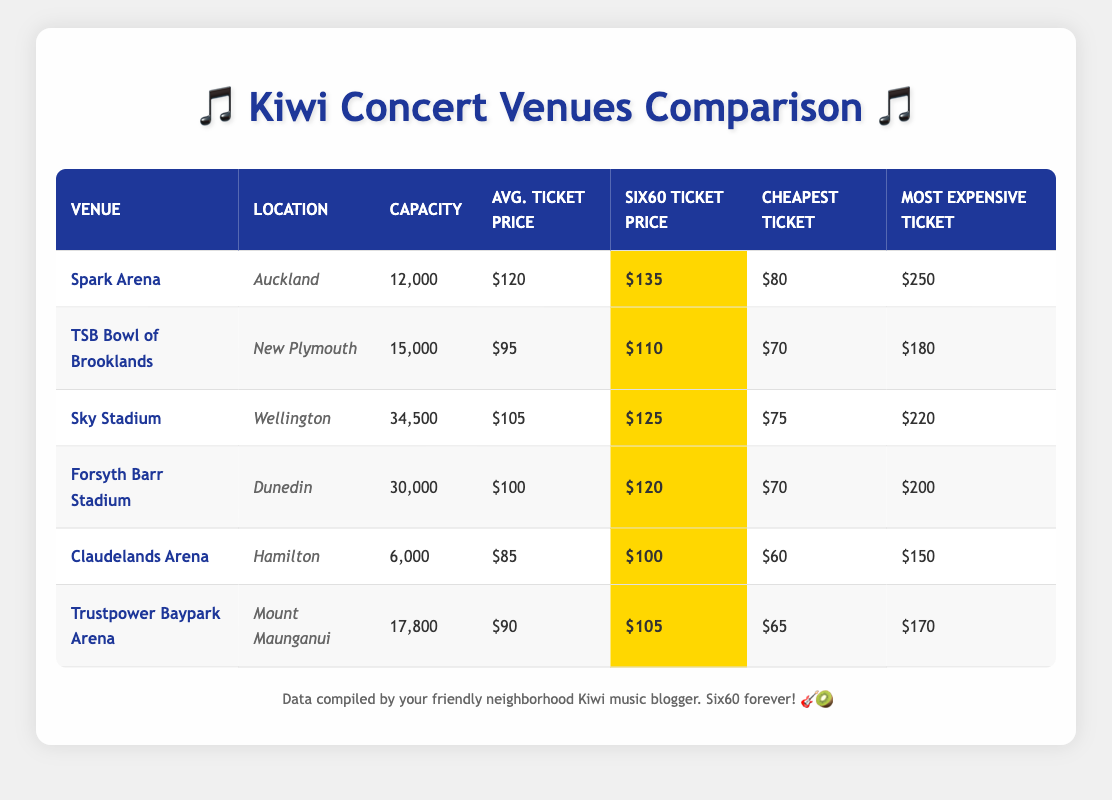What is the average ticket price at Spark Arena? The average ticket price at Spark Arena is listed directly in the table under the "Avg. Ticket Price" column. Referring to the table, the value is $120.
Answer: $120 Which venue has the highest most expensive ticket price? To determine this, I need to compare the "Most Expensive Ticket" column across all venues. The highest value is $250 at Spark Arena.
Answer: Spark Arena What is the difference between the cheapest and most expensive ticket price at Forsyth Barr Stadium? I check the cheapest ticket price, which is $70, and the most expensive, which is $200. The difference is calculated by subtracting the cheapest from the most expensive: 200 - 70 = 130.
Answer: $130 Is the Six60 ticket price at TSB Bowl of Brooklands higher than the average ticket price? To answer this, I compare the Six60 ticket price ($110) with the average ticket price ($95) at TSB Bowl of Brooklands. Since $110 is greater than $95, the statement is true.
Answer: Yes What is the average capacity of all the venues listed in the table? The capacities of all the venues are 12000, 15000, 34500, 30000, 6000, and 17800. To find the average, I sum these values: 12000 + 15000 + 34500 + 30000 + 6000 + 17800 = 113300, and then divide by the number of venues (6): 113300 / 6 = 18883.33.
Answer: 18883.33 Which venue has the cheapest ticket price overall, and what is that price? I need to compare the "Cheapest Ticket" column from each venue. The lowest value is $60 at Claudelands Arena.
Answer: Claudelands Arena, $60 How much more expensive is a Six60 ticket at Sky Stadium compared to the cheapest ticket at the same venue? At Sky Stadium, the Six60 ticket price is $125, and the cheapest ticket is $75. The difference is calculated as 125 - 75 = 50.
Answer: $50 How many venues have an average ticket price below $100? I check the "Avg. Ticket Price" column for each venue. The venues with prices below $100 are TSB Bowl of Brooklands ($95), Forsyth Barr Stadium ($100), Claudelands Arena ($85), and Trustpower Baypark Arena ($90). Counting these results reveals 4 venues.
Answer: 4 Is the most expensive ticket price at Trustpower Baypark Arena lower than $180? The most expensive ticket price at Trustpower Baypark Arena is $170. Since $170 is lower than $180, the answer is true.
Answer: Yes 